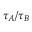Convert formula to latex. <formula><loc_0><loc_0><loc_500><loc_500>{ \tau _ { A } } / { \tau _ { B } }</formula> 